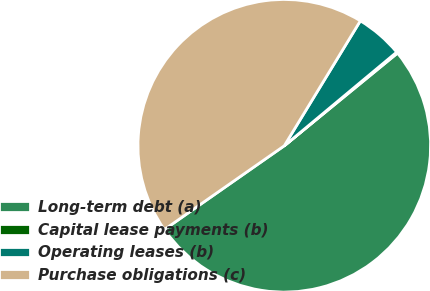Convert chart to OTSL. <chart><loc_0><loc_0><loc_500><loc_500><pie_chart><fcel>Long-term debt (a)<fcel>Capital lease payments (b)<fcel>Operating leases (b)<fcel>Purchase obligations (c)<nl><fcel>51.21%<fcel>0.14%<fcel>5.24%<fcel>43.41%<nl></chart> 